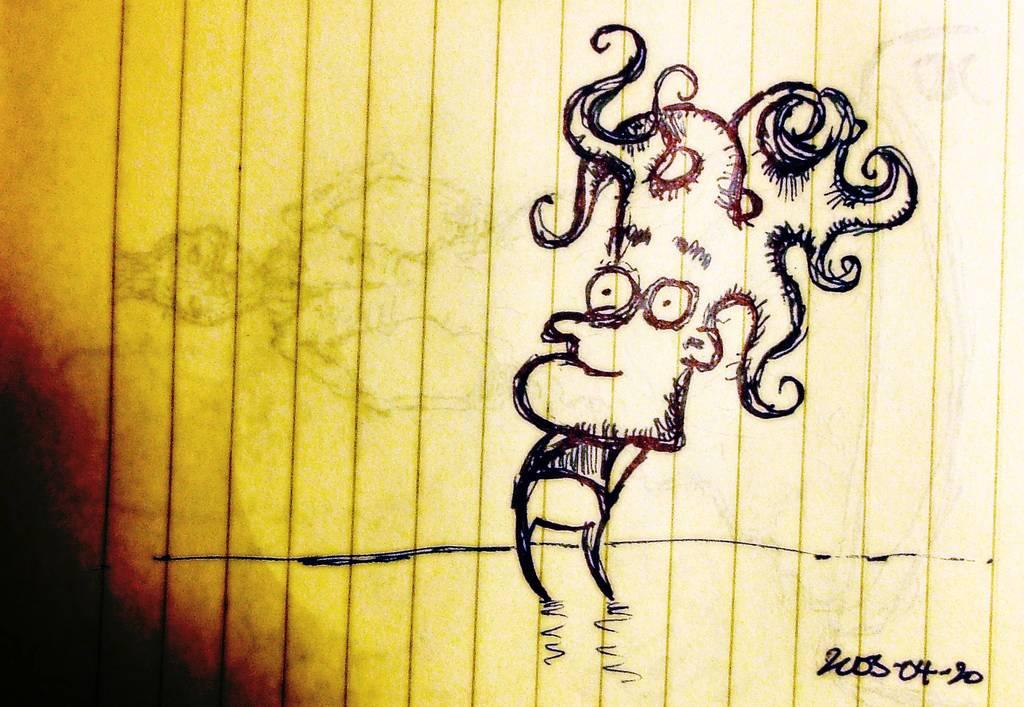What is depicted in the image? There is a drawing of a person in the image. What else can be found on the page in the image? There is text on the page in the image. What song is the person singing in the image? There is no indication of a song or singing in the image; it only shows a drawing of a person and text on the page. 